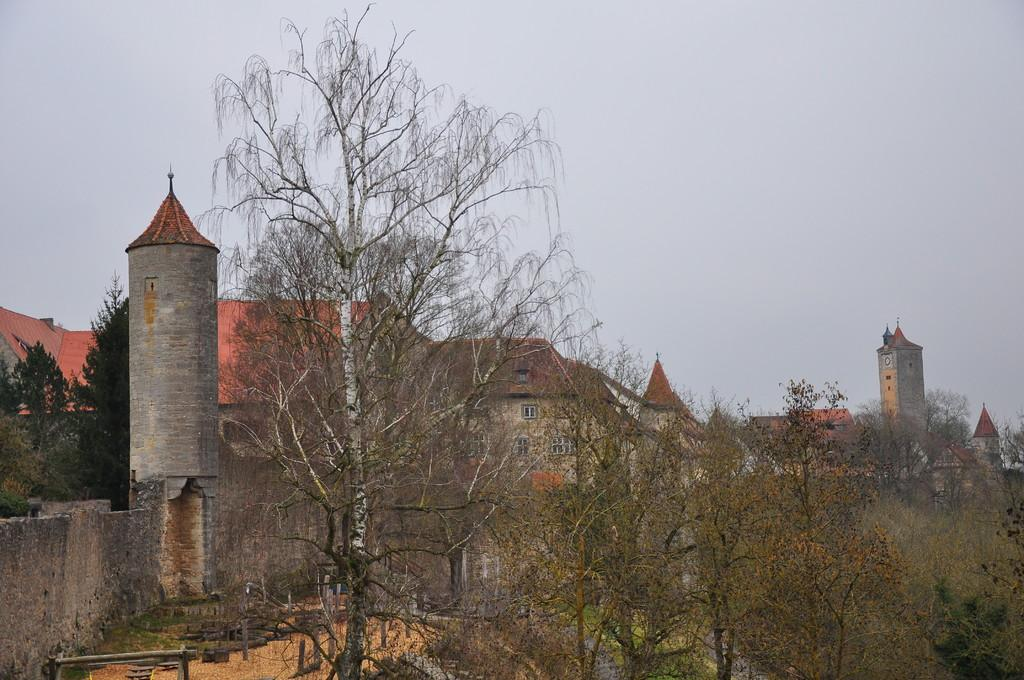What type of structures can be seen in the image? There are houses in the image. What feature is present in the houses that can be seen from the outside? There are windows visible in the image. What type of vegetation is present in the image? There are trees in the image. What objects made of wood can be seen in the image? There are wooden sticks in the image. What is visible in the background of the image? The sky is visible in the image. How many cacti are present in the image? There are no cacti present in the image. What type of credit is being offered to the beggar in the image? There is no beggar or credit mentioned in the image. 